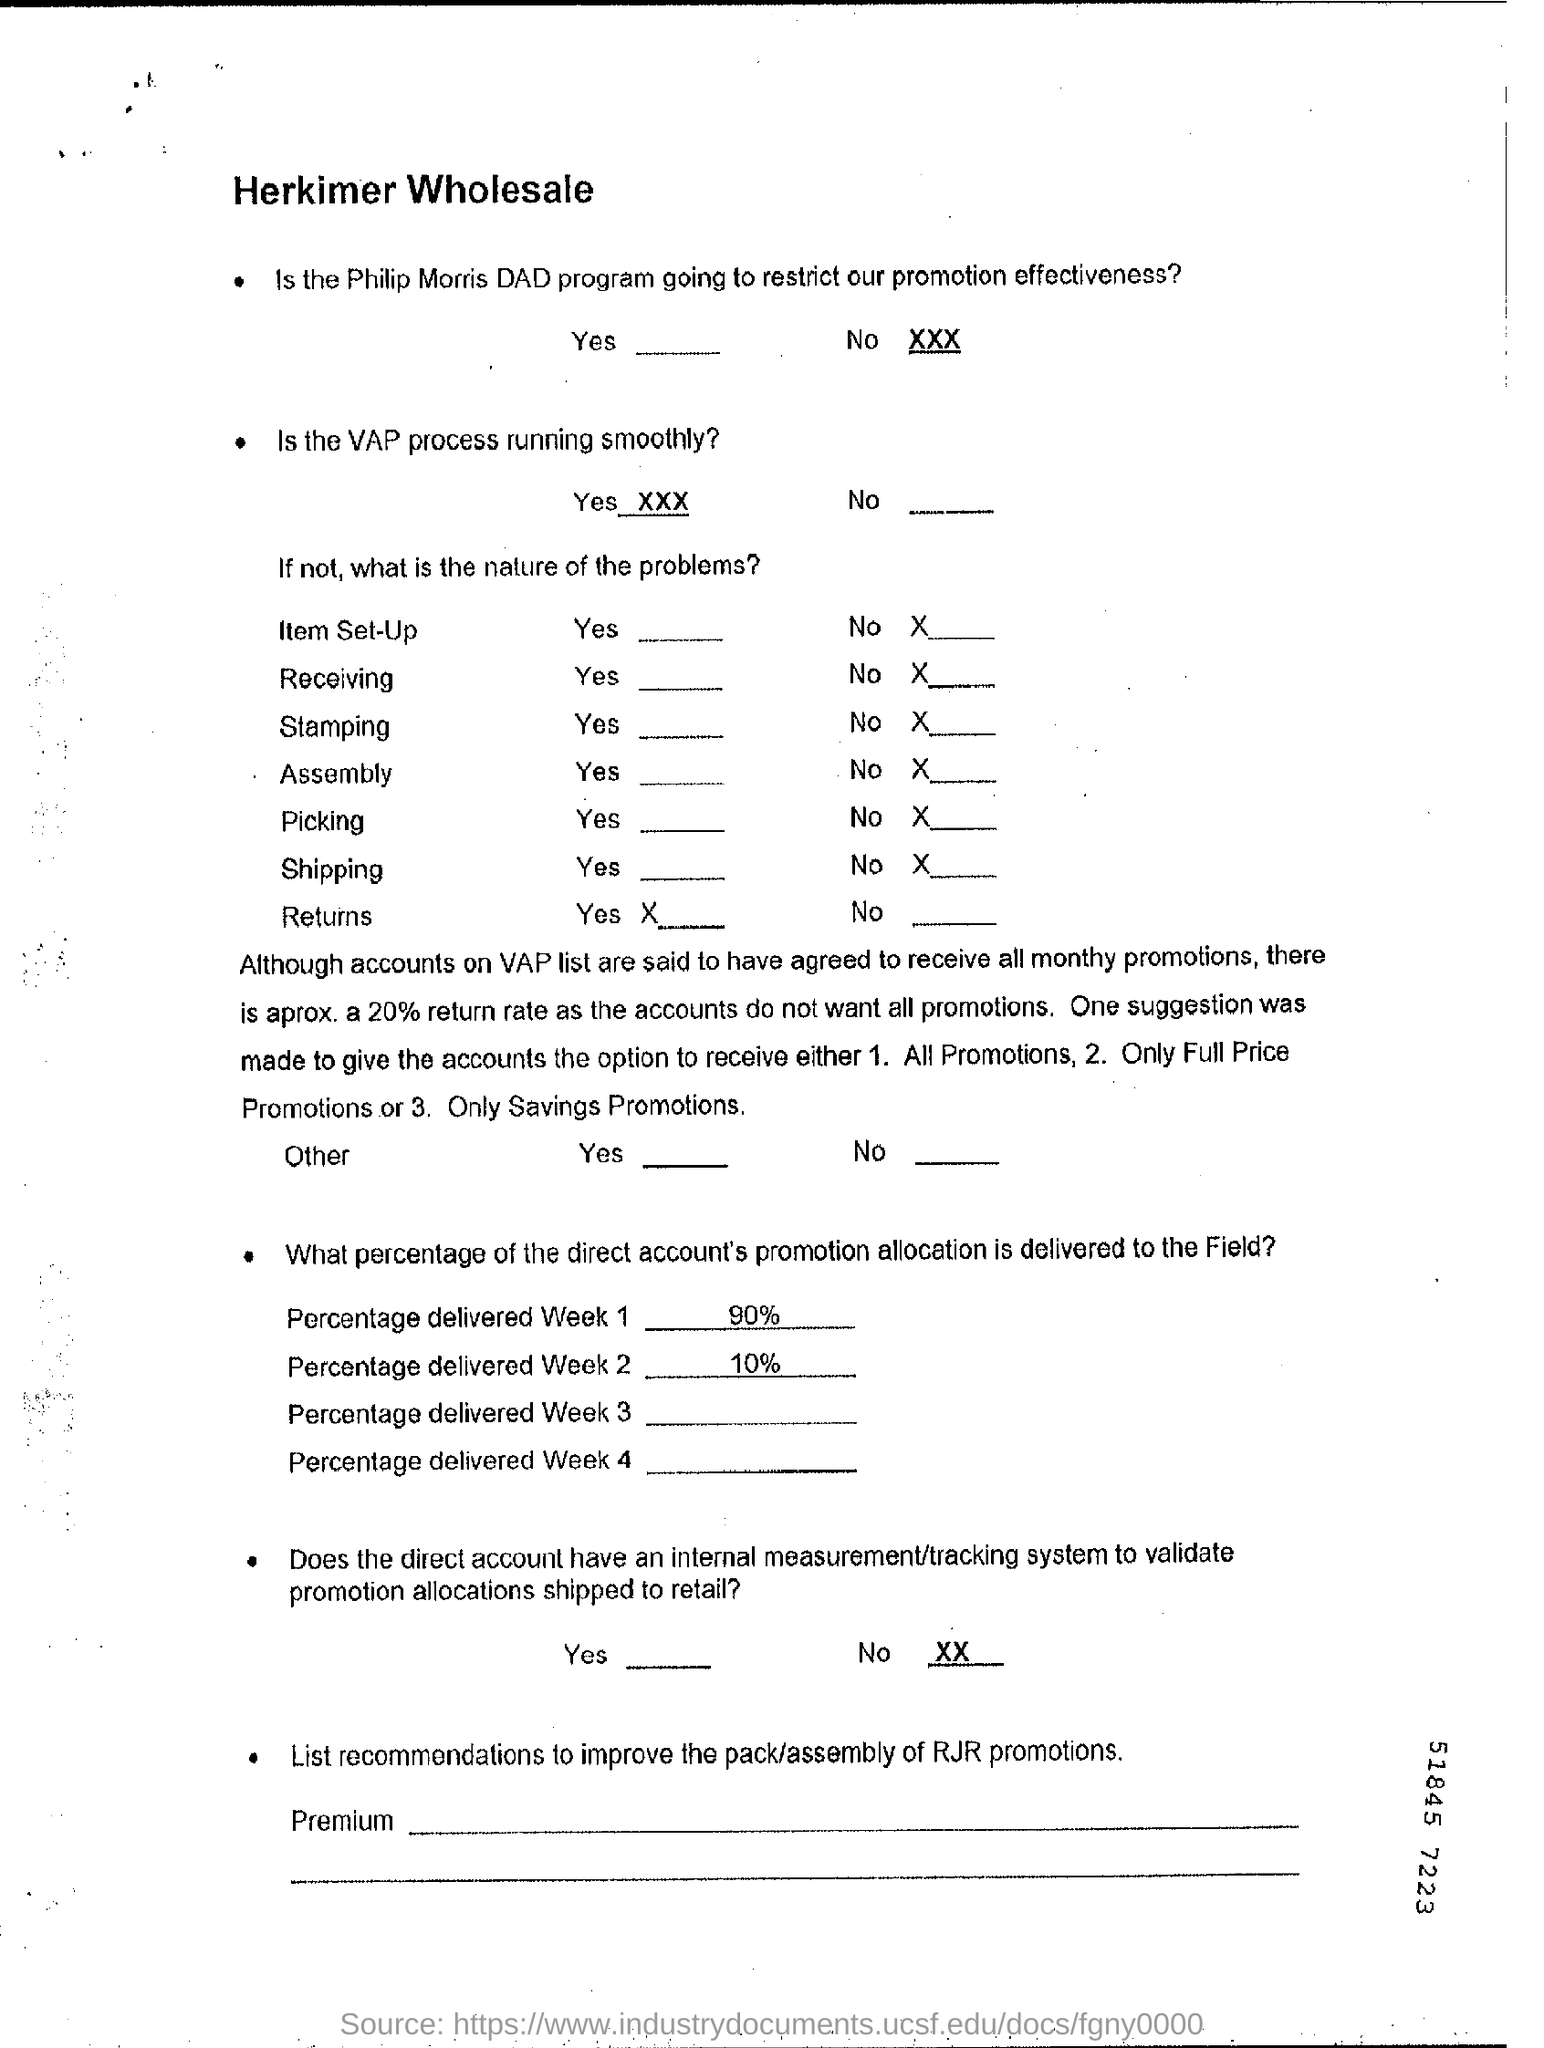Draw attention to some important aspects in this diagram. Yes, the VAP process is running smoothly. In week 2, 10% of the direct account's promotion allocation is delivered to the field. Approximately 90% of the direct account's promotion allocation was delivered to the field in the first week. The Philip Morris DAD program is not expected to hinder the effectiveness of our promotional efforts. 